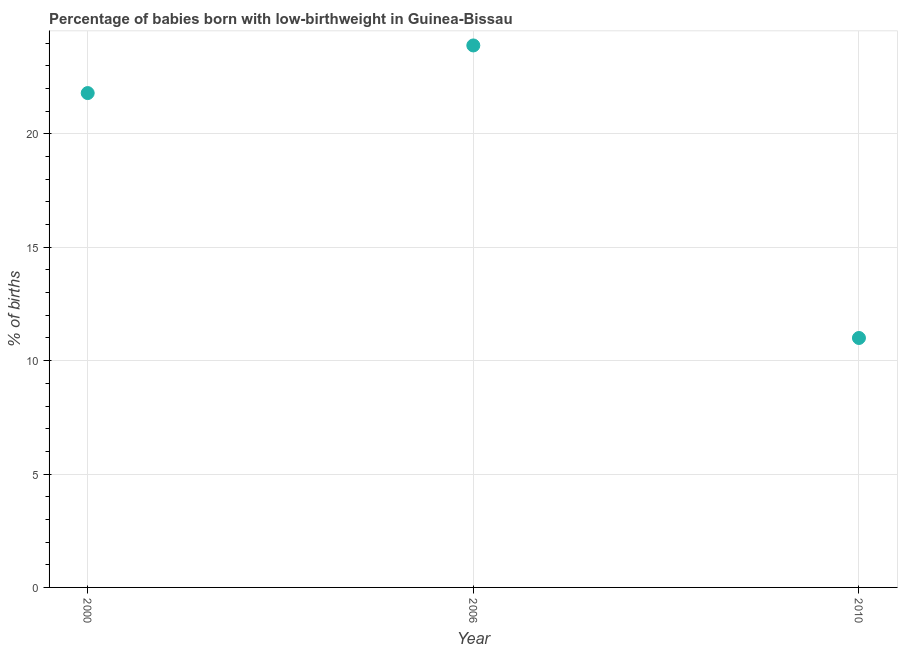What is the percentage of babies who were born with low-birthweight in 2006?
Provide a short and direct response. 23.9. Across all years, what is the maximum percentage of babies who were born with low-birthweight?
Your answer should be compact. 23.9. Across all years, what is the minimum percentage of babies who were born with low-birthweight?
Your answer should be very brief. 11. In which year was the percentage of babies who were born with low-birthweight maximum?
Provide a short and direct response. 2006. In which year was the percentage of babies who were born with low-birthweight minimum?
Make the answer very short. 2010. What is the sum of the percentage of babies who were born with low-birthweight?
Your answer should be compact. 56.7. What is the difference between the percentage of babies who were born with low-birthweight in 2000 and 2010?
Offer a terse response. 10.8. What is the average percentage of babies who were born with low-birthweight per year?
Provide a short and direct response. 18.9. What is the median percentage of babies who were born with low-birthweight?
Give a very brief answer. 21.8. In how many years, is the percentage of babies who were born with low-birthweight greater than 10 %?
Make the answer very short. 3. What is the ratio of the percentage of babies who were born with low-birthweight in 2000 to that in 2010?
Provide a short and direct response. 1.98. What is the difference between the highest and the second highest percentage of babies who were born with low-birthweight?
Your answer should be very brief. 2.1. Is the sum of the percentage of babies who were born with low-birthweight in 2000 and 2010 greater than the maximum percentage of babies who were born with low-birthweight across all years?
Your answer should be compact. Yes. What is the difference between the highest and the lowest percentage of babies who were born with low-birthweight?
Your answer should be very brief. 12.9. How many dotlines are there?
Keep it short and to the point. 1. What is the difference between two consecutive major ticks on the Y-axis?
Give a very brief answer. 5. Are the values on the major ticks of Y-axis written in scientific E-notation?
Your answer should be compact. No. Does the graph contain any zero values?
Offer a very short reply. No. Does the graph contain grids?
Your answer should be compact. Yes. What is the title of the graph?
Your answer should be compact. Percentage of babies born with low-birthweight in Guinea-Bissau. What is the label or title of the X-axis?
Provide a succinct answer. Year. What is the label or title of the Y-axis?
Provide a succinct answer. % of births. What is the % of births in 2000?
Provide a succinct answer. 21.8. What is the % of births in 2006?
Provide a succinct answer. 23.9. What is the % of births in 2010?
Your answer should be compact. 11. What is the difference between the % of births in 2000 and 2006?
Give a very brief answer. -2.1. What is the difference between the % of births in 2000 and 2010?
Provide a short and direct response. 10.8. What is the difference between the % of births in 2006 and 2010?
Provide a succinct answer. 12.9. What is the ratio of the % of births in 2000 to that in 2006?
Provide a succinct answer. 0.91. What is the ratio of the % of births in 2000 to that in 2010?
Make the answer very short. 1.98. What is the ratio of the % of births in 2006 to that in 2010?
Provide a short and direct response. 2.17. 